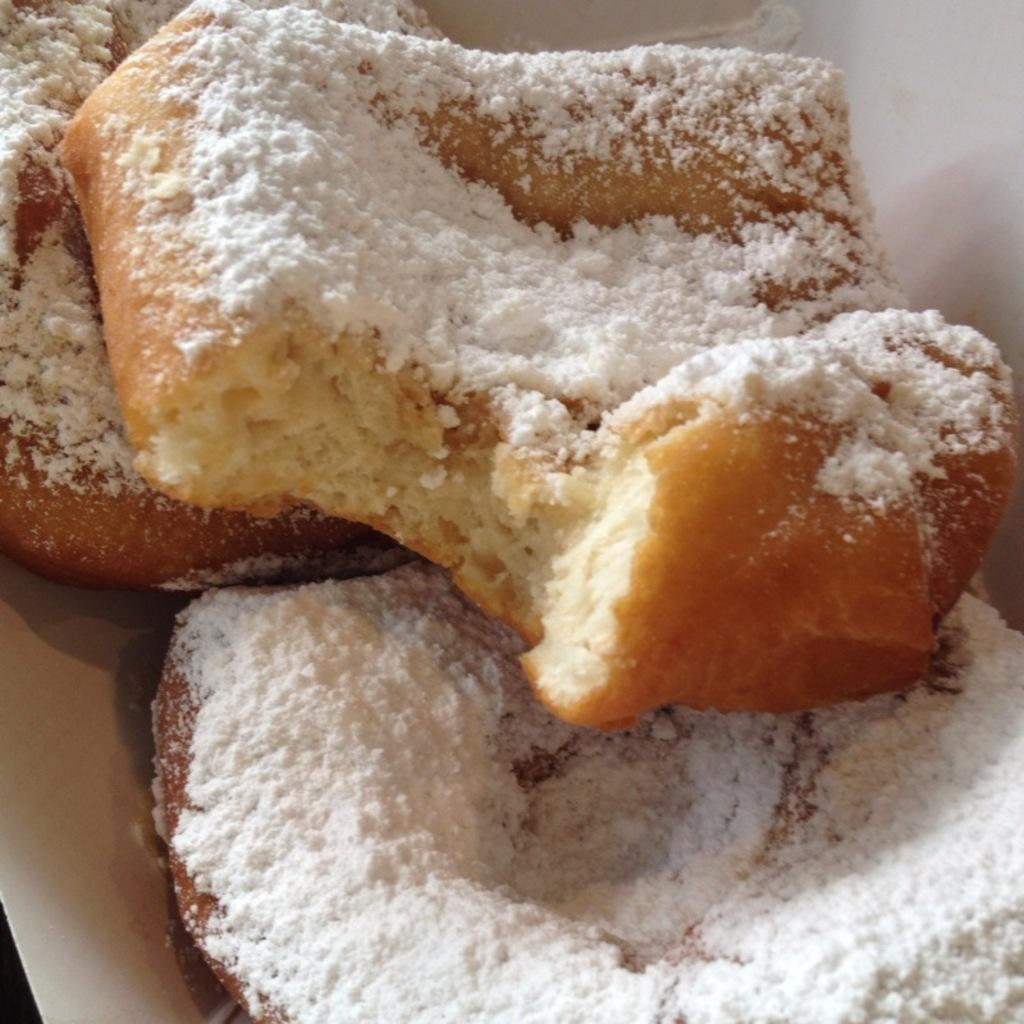What is present on the plate in the image? There are food items on the plate in the image. Can you describe the food items on the plate? Unfortunately, the specific food items cannot be determined from the provided facts. What is the nature of the argument taking place between the food items on the plate? There is no argument present in the image, as it only features a plate with food items. 